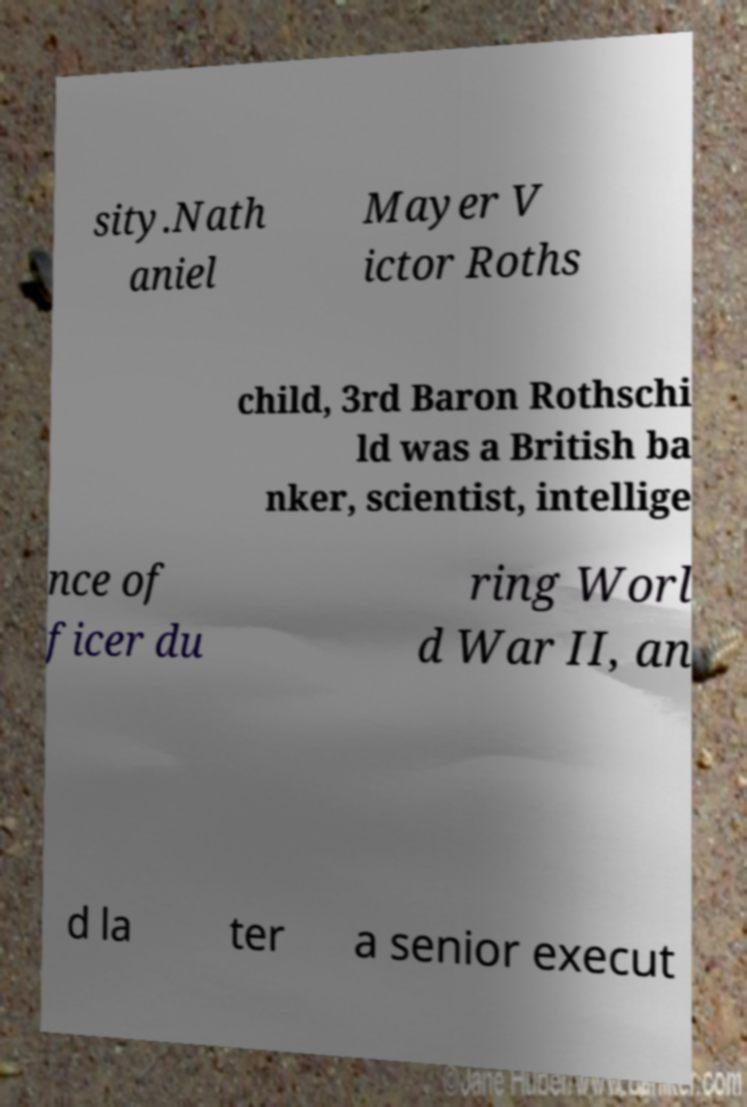What messages or text are displayed in this image? I need them in a readable, typed format. sity.Nath aniel Mayer V ictor Roths child, 3rd Baron Rothschi ld was a British ba nker, scientist, intellige nce of ficer du ring Worl d War II, an d la ter a senior execut 